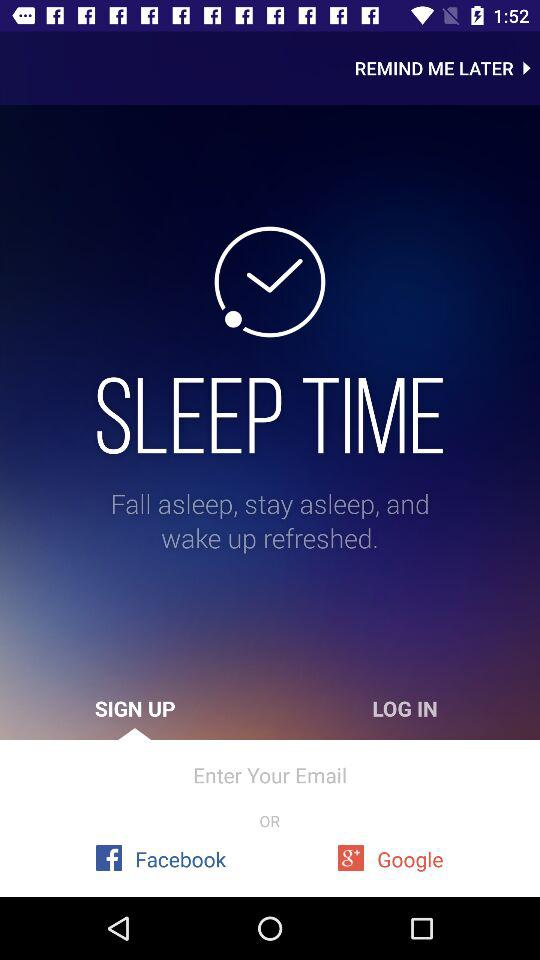What are the modes of sleep time?
When the provided information is insufficient, respond with <no answer>. <no answer> 